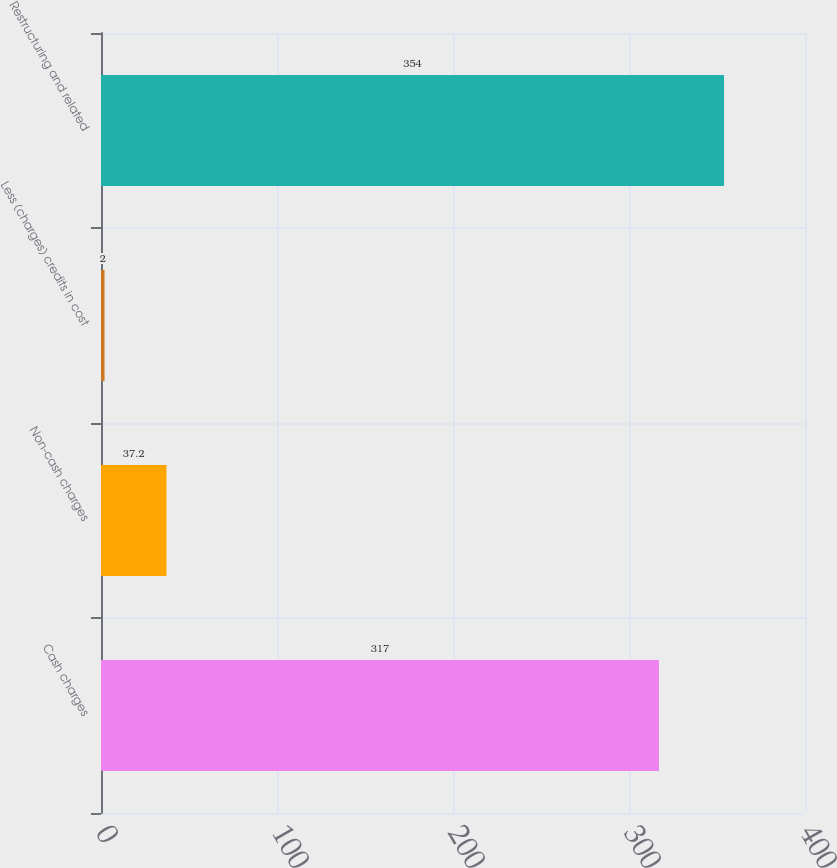<chart> <loc_0><loc_0><loc_500><loc_500><bar_chart><fcel>Cash charges<fcel>Non-cash charges<fcel>Less (charges) credits in cost<fcel>Restructuring and related<nl><fcel>317<fcel>37.2<fcel>2<fcel>354<nl></chart> 